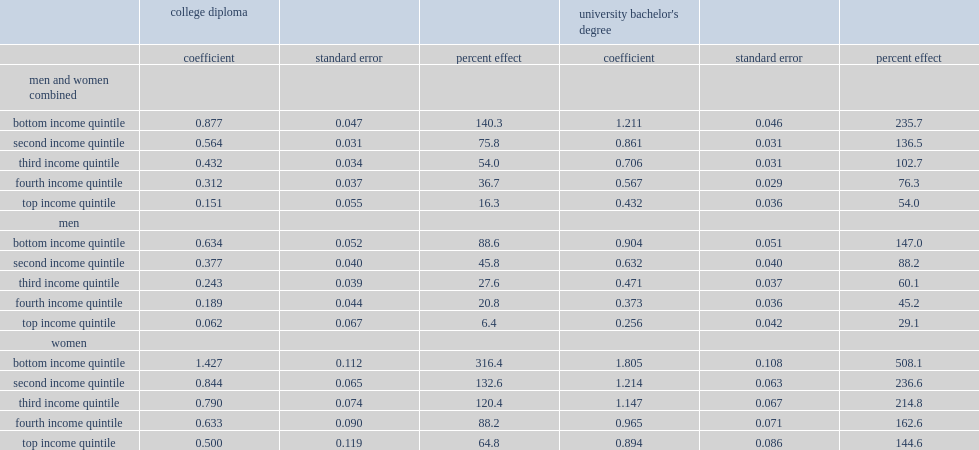What percentage did a university bachelor's degree associating with median earnings per year for youth from families in the bottom income quintile? 235.7. What percentage did a university bachelor's degree associating with median earnings per year for youth from families in the top income quintile? 54.0. What percentages did a college education associating with median earnings per year for youth from families in the bottom income quintile and the top income quintile respectively? 140.3 16.3. Which group did a college diploma and a university bachelor's degree associating with median earnings per year more,lower-income families or higher-income families? Bottom income quintile. 